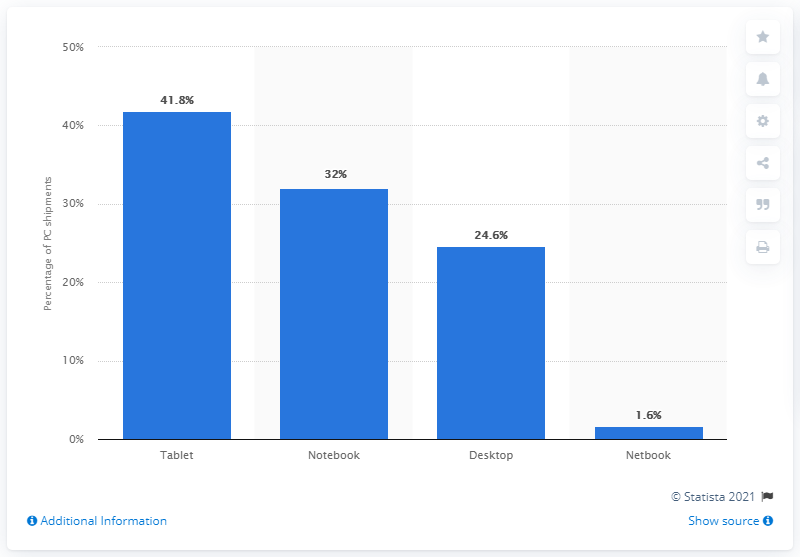Mention a couple of crucial points in this snapshot. According to projections, the market share of notebooks is expected to reach 32% in 2015. 